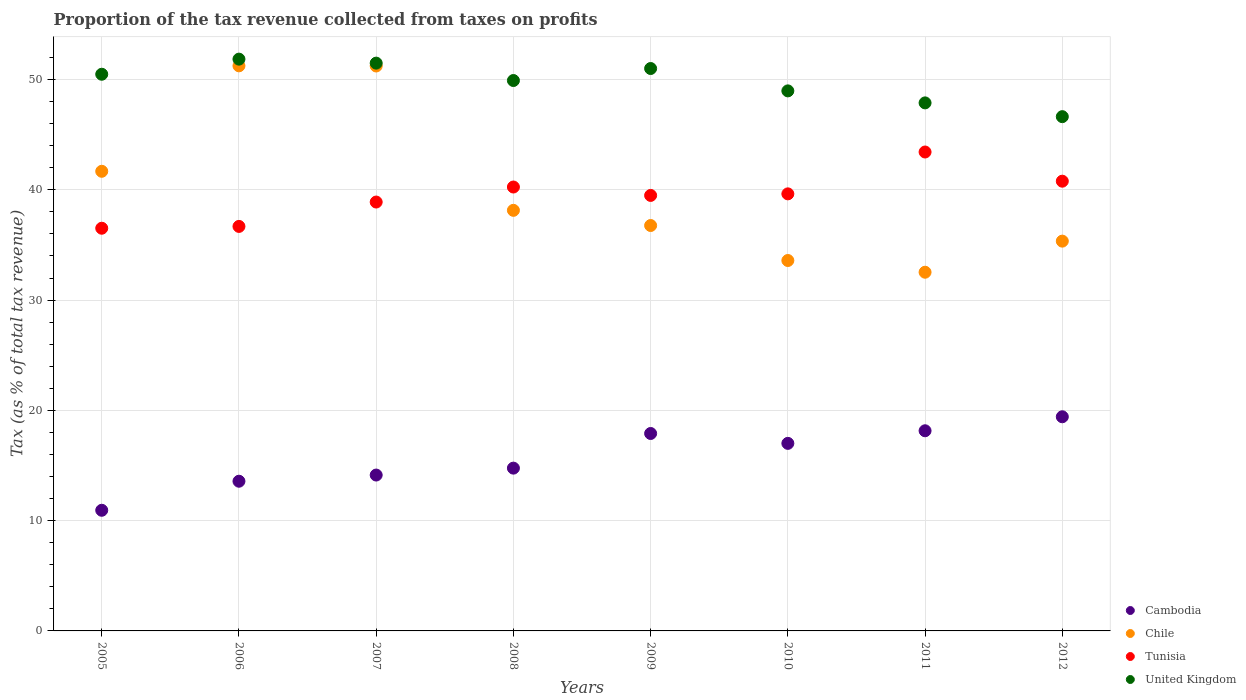How many different coloured dotlines are there?
Give a very brief answer. 4. What is the proportion of the tax revenue collected in Chile in 2012?
Make the answer very short. 35.35. Across all years, what is the maximum proportion of the tax revenue collected in Cambodia?
Your answer should be very brief. 19.42. Across all years, what is the minimum proportion of the tax revenue collected in Chile?
Offer a terse response. 32.53. What is the total proportion of the tax revenue collected in Chile in the graph?
Ensure brevity in your answer.  320.5. What is the difference between the proportion of the tax revenue collected in Tunisia in 2011 and that in 2012?
Give a very brief answer. 2.65. What is the difference between the proportion of the tax revenue collected in Tunisia in 2010 and the proportion of the tax revenue collected in United Kingdom in 2007?
Provide a short and direct response. -11.85. What is the average proportion of the tax revenue collected in Tunisia per year?
Ensure brevity in your answer.  39.46. In the year 2008, what is the difference between the proportion of the tax revenue collected in Chile and proportion of the tax revenue collected in United Kingdom?
Keep it short and to the point. -11.77. In how many years, is the proportion of the tax revenue collected in Cambodia greater than 8 %?
Offer a very short reply. 8. What is the ratio of the proportion of the tax revenue collected in Cambodia in 2008 to that in 2009?
Provide a succinct answer. 0.82. What is the difference between the highest and the second highest proportion of the tax revenue collected in Tunisia?
Offer a terse response. 2.65. What is the difference between the highest and the lowest proportion of the tax revenue collected in Cambodia?
Make the answer very short. 8.48. In how many years, is the proportion of the tax revenue collected in Tunisia greater than the average proportion of the tax revenue collected in Tunisia taken over all years?
Make the answer very short. 5. Is the sum of the proportion of the tax revenue collected in Chile in 2006 and 2012 greater than the maximum proportion of the tax revenue collected in United Kingdom across all years?
Ensure brevity in your answer.  Yes. Is it the case that in every year, the sum of the proportion of the tax revenue collected in United Kingdom and proportion of the tax revenue collected in Chile  is greater than the sum of proportion of the tax revenue collected in Tunisia and proportion of the tax revenue collected in Cambodia?
Make the answer very short. No. Is it the case that in every year, the sum of the proportion of the tax revenue collected in Cambodia and proportion of the tax revenue collected in Tunisia  is greater than the proportion of the tax revenue collected in United Kingdom?
Make the answer very short. No. Does the proportion of the tax revenue collected in Tunisia monotonically increase over the years?
Keep it short and to the point. No. Is the proportion of the tax revenue collected in Cambodia strictly greater than the proportion of the tax revenue collected in United Kingdom over the years?
Your answer should be very brief. No. How many dotlines are there?
Your answer should be compact. 4. Does the graph contain any zero values?
Make the answer very short. No. Does the graph contain grids?
Make the answer very short. Yes. What is the title of the graph?
Provide a short and direct response. Proportion of the tax revenue collected from taxes on profits. What is the label or title of the Y-axis?
Make the answer very short. Tax (as % of total tax revenue). What is the Tax (as % of total tax revenue) of Cambodia in 2005?
Your response must be concise. 10.94. What is the Tax (as % of total tax revenue) of Chile in 2005?
Ensure brevity in your answer.  41.68. What is the Tax (as % of total tax revenue) of Tunisia in 2005?
Keep it short and to the point. 36.51. What is the Tax (as % of total tax revenue) of United Kingdom in 2005?
Ensure brevity in your answer.  50.48. What is the Tax (as % of total tax revenue) in Cambodia in 2006?
Offer a terse response. 13.57. What is the Tax (as % of total tax revenue) of Chile in 2006?
Ensure brevity in your answer.  51.24. What is the Tax (as % of total tax revenue) of Tunisia in 2006?
Offer a very short reply. 36.68. What is the Tax (as % of total tax revenue) in United Kingdom in 2006?
Ensure brevity in your answer.  51.85. What is the Tax (as % of total tax revenue) of Cambodia in 2007?
Your response must be concise. 14.13. What is the Tax (as % of total tax revenue) of Chile in 2007?
Offer a very short reply. 51.23. What is the Tax (as % of total tax revenue) of Tunisia in 2007?
Your answer should be compact. 38.89. What is the Tax (as % of total tax revenue) of United Kingdom in 2007?
Provide a short and direct response. 51.49. What is the Tax (as % of total tax revenue) of Cambodia in 2008?
Your answer should be compact. 14.76. What is the Tax (as % of total tax revenue) of Chile in 2008?
Ensure brevity in your answer.  38.14. What is the Tax (as % of total tax revenue) in Tunisia in 2008?
Ensure brevity in your answer.  40.25. What is the Tax (as % of total tax revenue) in United Kingdom in 2008?
Your answer should be very brief. 49.91. What is the Tax (as % of total tax revenue) in Cambodia in 2009?
Your response must be concise. 17.9. What is the Tax (as % of total tax revenue) in Chile in 2009?
Your answer should be compact. 36.76. What is the Tax (as % of total tax revenue) of Tunisia in 2009?
Your answer should be very brief. 39.49. What is the Tax (as % of total tax revenue) of United Kingdom in 2009?
Provide a short and direct response. 51. What is the Tax (as % of total tax revenue) in Cambodia in 2010?
Give a very brief answer. 17.01. What is the Tax (as % of total tax revenue) of Chile in 2010?
Your answer should be compact. 33.59. What is the Tax (as % of total tax revenue) of Tunisia in 2010?
Keep it short and to the point. 39.63. What is the Tax (as % of total tax revenue) in United Kingdom in 2010?
Provide a succinct answer. 48.97. What is the Tax (as % of total tax revenue) in Cambodia in 2011?
Your answer should be compact. 18.15. What is the Tax (as % of total tax revenue) of Chile in 2011?
Your response must be concise. 32.53. What is the Tax (as % of total tax revenue) of Tunisia in 2011?
Ensure brevity in your answer.  43.43. What is the Tax (as % of total tax revenue) of United Kingdom in 2011?
Your response must be concise. 47.88. What is the Tax (as % of total tax revenue) in Cambodia in 2012?
Offer a very short reply. 19.42. What is the Tax (as % of total tax revenue) of Chile in 2012?
Your response must be concise. 35.35. What is the Tax (as % of total tax revenue) in Tunisia in 2012?
Give a very brief answer. 40.78. What is the Tax (as % of total tax revenue) in United Kingdom in 2012?
Make the answer very short. 46.63. Across all years, what is the maximum Tax (as % of total tax revenue) of Cambodia?
Provide a succinct answer. 19.42. Across all years, what is the maximum Tax (as % of total tax revenue) of Chile?
Your answer should be compact. 51.24. Across all years, what is the maximum Tax (as % of total tax revenue) in Tunisia?
Provide a succinct answer. 43.43. Across all years, what is the maximum Tax (as % of total tax revenue) of United Kingdom?
Ensure brevity in your answer.  51.85. Across all years, what is the minimum Tax (as % of total tax revenue) in Cambodia?
Offer a very short reply. 10.94. Across all years, what is the minimum Tax (as % of total tax revenue) in Chile?
Your answer should be compact. 32.53. Across all years, what is the minimum Tax (as % of total tax revenue) in Tunisia?
Your answer should be compact. 36.51. Across all years, what is the minimum Tax (as % of total tax revenue) in United Kingdom?
Keep it short and to the point. 46.63. What is the total Tax (as % of total tax revenue) in Cambodia in the graph?
Keep it short and to the point. 125.89. What is the total Tax (as % of total tax revenue) in Chile in the graph?
Offer a terse response. 320.5. What is the total Tax (as % of total tax revenue) of Tunisia in the graph?
Your response must be concise. 315.67. What is the total Tax (as % of total tax revenue) in United Kingdom in the graph?
Ensure brevity in your answer.  398.2. What is the difference between the Tax (as % of total tax revenue) of Cambodia in 2005 and that in 2006?
Provide a short and direct response. -2.63. What is the difference between the Tax (as % of total tax revenue) in Chile in 2005 and that in 2006?
Offer a terse response. -9.56. What is the difference between the Tax (as % of total tax revenue) in Tunisia in 2005 and that in 2006?
Ensure brevity in your answer.  -0.17. What is the difference between the Tax (as % of total tax revenue) in United Kingdom in 2005 and that in 2006?
Your answer should be compact. -1.37. What is the difference between the Tax (as % of total tax revenue) in Cambodia in 2005 and that in 2007?
Make the answer very short. -3.19. What is the difference between the Tax (as % of total tax revenue) in Chile in 2005 and that in 2007?
Make the answer very short. -9.55. What is the difference between the Tax (as % of total tax revenue) in Tunisia in 2005 and that in 2007?
Offer a terse response. -2.38. What is the difference between the Tax (as % of total tax revenue) of United Kingdom in 2005 and that in 2007?
Offer a terse response. -1.01. What is the difference between the Tax (as % of total tax revenue) in Cambodia in 2005 and that in 2008?
Offer a very short reply. -3.82. What is the difference between the Tax (as % of total tax revenue) in Chile in 2005 and that in 2008?
Offer a terse response. 3.54. What is the difference between the Tax (as % of total tax revenue) of Tunisia in 2005 and that in 2008?
Your response must be concise. -3.74. What is the difference between the Tax (as % of total tax revenue) of United Kingdom in 2005 and that in 2008?
Make the answer very short. 0.57. What is the difference between the Tax (as % of total tax revenue) in Cambodia in 2005 and that in 2009?
Your answer should be very brief. -6.96. What is the difference between the Tax (as % of total tax revenue) in Chile in 2005 and that in 2009?
Your answer should be very brief. 4.92. What is the difference between the Tax (as % of total tax revenue) of Tunisia in 2005 and that in 2009?
Give a very brief answer. -2.98. What is the difference between the Tax (as % of total tax revenue) in United Kingdom in 2005 and that in 2009?
Offer a very short reply. -0.52. What is the difference between the Tax (as % of total tax revenue) of Cambodia in 2005 and that in 2010?
Make the answer very short. -6.07. What is the difference between the Tax (as % of total tax revenue) in Chile in 2005 and that in 2010?
Offer a terse response. 8.09. What is the difference between the Tax (as % of total tax revenue) in Tunisia in 2005 and that in 2010?
Give a very brief answer. -3.12. What is the difference between the Tax (as % of total tax revenue) in United Kingdom in 2005 and that in 2010?
Provide a succinct answer. 1.51. What is the difference between the Tax (as % of total tax revenue) in Cambodia in 2005 and that in 2011?
Keep it short and to the point. -7.21. What is the difference between the Tax (as % of total tax revenue) in Chile in 2005 and that in 2011?
Keep it short and to the point. 9.15. What is the difference between the Tax (as % of total tax revenue) in Tunisia in 2005 and that in 2011?
Ensure brevity in your answer.  -6.91. What is the difference between the Tax (as % of total tax revenue) of United Kingdom in 2005 and that in 2011?
Your answer should be very brief. 2.6. What is the difference between the Tax (as % of total tax revenue) in Cambodia in 2005 and that in 2012?
Your response must be concise. -8.48. What is the difference between the Tax (as % of total tax revenue) of Chile in 2005 and that in 2012?
Provide a succinct answer. 6.33. What is the difference between the Tax (as % of total tax revenue) in Tunisia in 2005 and that in 2012?
Provide a succinct answer. -4.27. What is the difference between the Tax (as % of total tax revenue) in United Kingdom in 2005 and that in 2012?
Provide a succinct answer. 3.85. What is the difference between the Tax (as % of total tax revenue) in Cambodia in 2006 and that in 2007?
Ensure brevity in your answer.  -0.56. What is the difference between the Tax (as % of total tax revenue) in Chile in 2006 and that in 2007?
Offer a terse response. 0.01. What is the difference between the Tax (as % of total tax revenue) of Tunisia in 2006 and that in 2007?
Your answer should be very brief. -2.21. What is the difference between the Tax (as % of total tax revenue) in United Kingdom in 2006 and that in 2007?
Ensure brevity in your answer.  0.36. What is the difference between the Tax (as % of total tax revenue) in Cambodia in 2006 and that in 2008?
Ensure brevity in your answer.  -1.19. What is the difference between the Tax (as % of total tax revenue) of Chile in 2006 and that in 2008?
Provide a short and direct response. 13.1. What is the difference between the Tax (as % of total tax revenue) of Tunisia in 2006 and that in 2008?
Give a very brief answer. -3.57. What is the difference between the Tax (as % of total tax revenue) in United Kingdom in 2006 and that in 2008?
Your answer should be compact. 1.94. What is the difference between the Tax (as % of total tax revenue) of Cambodia in 2006 and that in 2009?
Your answer should be very brief. -4.33. What is the difference between the Tax (as % of total tax revenue) in Chile in 2006 and that in 2009?
Provide a succinct answer. 14.48. What is the difference between the Tax (as % of total tax revenue) in Tunisia in 2006 and that in 2009?
Offer a terse response. -2.81. What is the difference between the Tax (as % of total tax revenue) in United Kingdom in 2006 and that in 2009?
Your response must be concise. 0.85. What is the difference between the Tax (as % of total tax revenue) of Cambodia in 2006 and that in 2010?
Your response must be concise. -3.43. What is the difference between the Tax (as % of total tax revenue) of Chile in 2006 and that in 2010?
Your response must be concise. 17.65. What is the difference between the Tax (as % of total tax revenue) of Tunisia in 2006 and that in 2010?
Offer a terse response. -2.95. What is the difference between the Tax (as % of total tax revenue) of United Kingdom in 2006 and that in 2010?
Give a very brief answer. 2.88. What is the difference between the Tax (as % of total tax revenue) in Cambodia in 2006 and that in 2011?
Your response must be concise. -4.58. What is the difference between the Tax (as % of total tax revenue) in Chile in 2006 and that in 2011?
Your answer should be very brief. 18.71. What is the difference between the Tax (as % of total tax revenue) of Tunisia in 2006 and that in 2011?
Offer a very short reply. -6.75. What is the difference between the Tax (as % of total tax revenue) in United Kingdom in 2006 and that in 2011?
Offer a terse response. 3.97. What is the difference between the Tax (as % of total tax revenue) in Cambodia in 2006 and that in 2012?
Ensure brevity in your answer.  -5.84. What is the difference between the Tax (as % of total tax revenue) in Chile in 2006 and that in 2012?
Give a very brief answer. 15.9. What is the difference between the Tax (as % of total tax revenue) of Tunisia in 2006 and that in 2012?
Give a very brief answer. -4.1. What is the difference between the Tax (as % of total tax revenue) of United Kingdom in 2006 and that in 2012?
Give a very brief answer. 5.22. What is the difference between the Tax (as % of total tax revenue) of Cambodia in 2007 and that in 2008?
Ensure brevity in your answer.  -0.63. What is the difference between the Tax (as % of total tax revenue) of Chile in 2007 and that in 2008?
Provide a succinct answer. 13.09. What is the difference between the Tax (as % of total tax revenue) in Tunisia in 2007 and that in 2008?
Make the answer very short. -1.36. What is the difference between the Tax (as % of total tax revenue) in United Kingdom in 2007 and that in 2008?
Provide a succinct answer. 1.58. What is the difference between the Tax (as % of total tax revenue) of Cambodia in 2007 and that in 2009?
Give a very brief answer. -3.77. What is the difference between the Tax (as % of total tax revenue) of Chile in 2007 and that in 2009?
Your answer should be compact. 14.46. What is the difference between the Tax (as % of total tax revenue) in Tunisia in 2007 and that in 2009?
Your answer should be compact. -0.6. What is the difference between the Tax (as % of total tax revenue) in United Kingdom in 2007 and that in 2009?
Keep it short and to the point. 0.49. What is the difference between the Tax (as % of total tax revenue) of Cambodia in 2007 and that in 2010?
Provide a succinct answer. -2.87. What is the difference between the Tax (as % of total tax revenue) in Chile in 2007 and that in 2010?
Give a very brief answer. 17.64. What is the difference between the Tax (as % of total tax revenue) of Tunisia in 2007 and that in 2010?
Ensure brevity in your answer.  -0.74. What is the difference between the Tax (as % of total tax revenue) of United Kingdom in 2007 and that in 2010?
Keep it short and to the point. 2.52. What is the difference between the Tax (as % of total tax revenue) of Cambodia in 2007 and that in 2011?
Provide a short and direct response. -4.02. What is the difference between the Tax (as % of total tax revenue) of Chile in 2007 and that in 2011?
Make the answer very short. 18.7. What is the difference between the Tax (as % of total tax revenue) in Tunisia in 2007 and that in 2011?
Offer a very short reply. -4.54. What is the difference between the Tax (as % of total tax revenue) of United Kingdom in 2007 and that in 2011?
Your answer should be very brief. 3.61. What is the difference between the Tax (as % of total tax revenue) of Cambodia in 2007 and that in 2012?
Your answer should be very brief. -5.28. What is the difference between the Tax (as % of total tax revenue) in Chile in 2007 and that in 2012?
Provide a succinct answer. 15.88. What is the difference between the Tax (as % of total tax revenue) in Tunisia in 2007 and that in 2012?
Keep it short and to the point. -1.89. What is the difference between the Tax (as % of total tax revenue) of United Kingdom in 2007 and that in 2012?
Offer a very short reply. 4.85. What is the difference between the Tax (as % of total tax revenue) of Cambodia in 2008 and that in 2009?
Offer a very short reply. -3.14. What is the difference between the Tax (as % of total tax revenue) in Chile in 2008 and that in 2009?
Provide a short and direct response. 1.38. What is the difference between the Tax (as % of total tax revenue) of Tunisia in 2008 and that in 2009?
Make the answer very short. 0.76. What is the difference between the Tax (as % of total tax revenue) of United Kingdom in 2008 and that in 2009?
Your response must be concise. -1.09. What is the difference between the Tax (as % of total tax revenue) of Cambodia in 2008 and that in 2010?
Give a very brief answer. -2.25. What is the difference between the Tax (as % of total tax revenue) in Chile in 2008 and that in 2010?
Offer a terse response. 4.55. What is the difference between the Tax (as % of total tax revenue) in Tunisia in 2008 and that in 2010?
Make the answer very short. 0.62. What is the difference between the Tax (as % of total tax revenue) of United Kingdom in 2008 and that in 2010?
Give a very brief answer. 0.94. What is the difference between the Tax (as % of total tax revenue) in Cambodia in 2008 and that in 2011?
Offer a very short reply. -3.39. What is the difference between the Tax (as % of total tax revenue) in Chile in 2008 and that in 2011?
Offer a very short reply. 5.61. What is the difference between the Tax (as % of total tax revenue) of Tunisia in 2008 and that in 2011?
Make the answer very short. -3.18. What is the difference between the Tax (as % of total tax revenue) of United Kingdom in 2008 and that in 2011?
Your response must be concise. 2.03. What is the difference between the Tax (as % of total tax revenue) in Cambodia in 2008 and that in 2012?
Provide a succinct answer. -4.66. What is the difference between the Tax (as % of total tax revenue) in Chile in 2008 and that in 2012?
Offer a very short reply. 2.79. What is the difference between the Tax (as % of total tax revenue) of Tunisia in 2008 and that in 2012?
Ensure brevity in your answer.  -0.53. What is the difference between the Tax (as % of total tax revenue) of United Kingdom in 2008 and that in 2012?
Give a very brief answer. 3.28. What is the difference between the Tax (as % of total tax revenue) in Cambodia in 2009 and that in 2010?
Offer a very short reply. 0.9. What is the difference between the Tax (as % of total tax revenue) in Chile in 2009 and that in 2010?
Ensure brevity in your answer.  3.17. What is the difference between the Tax (as % of total tax revenue) of Tunisia in 2009 and that in 2010?
Offer a very short reply. -0.14. What is the difference between the Tax (as % of total tax revenue) of United Kingdom in 2009 and that in 2010?
Keep it short and to the point. 2.03. What is the difference between the Tax (as % of total tax revenue) in Cambodia in 2009 and that in 2011?
Provide a short and direct response. -0.25. What is the difference between the Tax (as % of total tax revenue) in Chile in 2009 and that in 2011?
Provide a succinct answer. 4.24. What is the difference between the Tax (as % of total tax revenue) of Tunisia in 2009 and that in 2011?
Your response must be concise. -3.94. What is the difference between the Tax (as % of total tax revenue) of United Kingdom in 2009 and that in 2011?
Give a very brief answer. 3.12. What is the difference between the Tax (as % of total tax revenue) of Cambodia in 2009 and that in 2012?
Make the answer very short. -1.52. What is the difference between the Tax (as % of total tax revenue) of Chile in 2009 and that in 2012?
Your answer should be very brief. 1.42. What is the difference between the Tax (as % of total tax revenue) of Tunisia in 2009 and that in 2012?
Provide a succinct answer. -1.29. What is the difference between the Tax (as % of total tax revenue) of United Kingdom in 2009 and that in 2012?
Provide a short and direct response. 4.37. What is the difference between the Tax (as % of total tax revenue) of Cambodia in 2010 and that in 2011?
Give a very brief answer. -1.14. What is the difference between the Tax (as % of total tax revenue) in Chile in 2010 and that in 2011?
Provide a succinct answer. 1.06. What is the difference between the Tax (as % of total tax revenue) of Tunisia in 2010 and that in 2011?
Offer a very short reply. -3.8. What is the difference between the Tax (as % of total tax revenue) in United Kingdom in 2010 and that in 2011?
Keep it short and to the point. 1.09. What is the difference between the Tax (as % of total tax revenue) in Cambodia in 2010 and that in 2012?
Keep it short and to the point. -2.41. What is the difference between the Tax (as % of total tax revenue) in Chile in 2010 and that in 2012?
Make the answer very short. -1.76. What is the difference between the Tax (as % of total tax revenue) of Tunisia in 2010 and that in 2012?
Your answer should be very brief. -1.15. What is the difference between the Tax (as % of total tax revenue) of United Kingdom in 2010 and that in 2012?
Offer a very short reply. 2.34. What is the difference between the Tax (as % of total tax revenue) of Cambodia in 2011 and that in 2012?
Keep it short and to the point. -1.27. What is the difference between the Tax (as % of total tax revenue) in Chile in 2011 and that in 2012?
Your answer should be compact. -2.82. What is the difference between the Tax (as % of total tax revenue) in Tunisia in 2011 and that in 2012?
Your answer should be very brief. 2.65. What is the difference between the Tax (as % of total tax revenue) in United Kingdom in 2011 and that in 2012?
Give a very brief answer. 1.25. What is the difference between the Tax (as % of total tax revenue) in Cambodia in 2005 and the Tax (as % of total tax revenue) in Chile in 2006?
Your response must be concise. -40.3. What is the difference between the Tax (as % of total tax revenue) in Cambodia in 2005 and the Tax (as % of total tax revenue) in Tunisia in 2006?
Offer a terse response. -25.74. What is the difference between the Tax (as % of total tax revenue) in Cambodia in 2005 and the Tax (as % of total tax revenue) in United Kingdom in 2006?
Provide a succinct answer. -40.91. What is the difference between the Tax (as % of total tax revenue) in Chile in 2005 and the Tax (as % of total tax revenue) in Tunisia in 2006?
Your answer should be very brief. 5. What is the difference between the Tax (as % of total tax revenue) of Chile in 2005 and the Tax (as % of total tax revenue) of United Kingdom in 2006?
Offer a very short reply. -10.17. What is the difference between the Tax (as % of total tax revenue) in Tunisia in 2005 and the Tax (as % of total tax revenue) in United Kingdom in 2006?
Offer a very short reply. -15.33. What is the difference between the Tax (as % of total tax revenue) of Cambodia in 2005 and the Tax (as % of total tax revenue) of Chile in 2007?
Provide a short and direct response. -40.29. What is the difference between the Tax (as % of total tax revenue) of Cambodia in 2005 and the Tax (as % of total tax revenue) of Tunisia in 2007?
Offer a terse response. -27.95. What is the difference between the Tax (as % of total tax revenue) of Cambodia in 2005 and the Tax (as % of total tax revenue) of United Kingdom in 2007?
Provide a succinct answer. -40.55. What is the difference between the Tax (as % of total tax revenue) of Chile in 2005 and the Tax (as % of total tax revenue) of Tunisia in 2007?
Your answer should be very brief. 2.79. What is the difference between the Tax (as % of total tax revenue) of Chile in 2005 and the Tax (as % of total tax revenue) of United Kingdom in 2007?
Your answer should be compact. -9.81. What is the difference between the Tax (as % of total tax revenue) of Tunisia in 2005 and the Tax (as % of total tax revenue) of United Kingdom in 2007?
Keep it short and to the point. -14.97. What is the difference between the Tax (as % of total tax revenue) of Cambodia in 2005 and the Tax (as % of total tax revenue) of Chile in 2008?
Offer a terse response. -27.2. What is the difference between the Tax (as % of total tax revenue) in Cambodia in 2005 and the Tax (as % of total tax revenue) in Tunisia in 2008?
Provide a short and direct response. -29.31. What is the difference between the Tax (as % of total tax revenue) of Cambodia in 2005 and the Tax (as % of total tax revenue) of United Kingdom in 2008?
Provide a succinct answer. -38.97. What is the difference between the Tax (as % of total tax revenue) in Chile in 2005 and the Tax (as % of total tax revenue) in Tunisia in 2008?
Ensure brevity in your answer.  1.43. What is the difference between the Tax (as % of total tax revenue) of Chile in 2005 and the Tax (as % of total tax revenue) of United Kingdom in 2008?
Your answer should be compact. -8.23. What is the difference between the Tax (as % of total tax revenue) in Tunisia in 2005 and the Tax (as % of total tax revenue) in United Kingdom in 2008?
Offer a terse response. -13.39. What is the difference between the Tax (as % of total tax revenue) of Cambodia in 2005 and the Tax (as % of total tax revenue) of Chile in 2009?
Provide a succinct answer. -25.82. What is the difference between the Tax (as % of total tax revenue) of Cambodia in 2005 and the Tax (as % of total tax revenue) of Tunisia in 2009?
Offer a terse response. -28.55. What is the difference between the Tax (as % of total tax revenue) of Cambodia in 2005 and the Tax (as % of total tax revenue) of United Kingdom in 2009?
Your answer should be very brief. -40.06. What is the difference between the Tax (as % of total tax revenue) in Chile in 2005 and the Tax (as % of total tax revenue) in Tunisia in 2009?
Provide a short and direct response. 2.19. What is the difference between the Tax (as % of total tax revenue) in Chile in 2005 and the Tax (as % of total tax revenue) in United Kingdom in 2009?
Provide a short and direct response. -9.32. What is the difference between the Tax (as % of total tax revenue) of Tunisia in 2005 and the Tax (as % of total tax revenue) of United Kingdom in 2009?
Make the answer very short. -14.48. What is the difference between the Tax (as % of total tax revenue) in Cambodia in 2005 and the Tax (as % of total tax revenue) in Chile in 2010?
Give a very brief answer. -22.65. What is the difference between the Tax (as % of total tax revenue) in Cambodia in 2005 and the Tax (as % of total tax revenue) in Tunisia in 2010?
Provide a succinct answer. -28.69. What is the difference between the Tax (as % of total tax revenue) of Cambodia in 2005 and the Tax (as % of total tax revenue) of United Kingdom in 2010?
Give a very brief answer. -38.03. What is the difference between the Tax (as % of total tax revenue) in Chile in 2005 and the Tax (as % of total tax revenue) in Tunisia in 2010?
Give a very brief answer. 2.05. What is the difference between the Tax (as % of total tax revenue) in Chile in 2005 and the Tax (as % of total tax revenue) in United Kingdom in 2010?
Offer a very short reply. -7.29. What is the difference between the Tax (as % of total tax revenue) of Tunisia in 2005 and the Tax (as % of total tax revenue) of United Kingdom in 2010?
Give a very brief answer. -12.46. What is the difference between the Tax (as % of total tax revenue) of Cambodia in 2005 and the Tax (as % of total tax revenue) of Chile in 2011?
Your answer should be very brief. -21.59. What is the difference between the Tax (as % of total tax revenue) of Cambodia in 2005 and the Tax (as % of total tax revenue) of Tunisia in 2011?
Make the answer very short. -32.49. What is the difference between the Tax (as % of total tax revenue) of Cambodia in 2005 and the Tax (as % of total tax revenue) of United Kingdom in 2011?
Offer a terse response. -36.94. What is the difference between the Tax (as % of total tax revenue) in Chile in 2005 and the Tax (as % of total tax revenue) in Tunisia in 2011?
Your response must be concise. -1.75. What is the difference between the Tax (as % of total tax revenue) in Chile in 2005 and the Tax (as % of total tax revenue) in United Kingdom in 2011?
Your answer should be compact. -6.2. What is the difference between the Tax (as % of total tax revenue) of Tunisia in 2005 and the Tax (as % of total tax revenue) of United Kingdom in 2011?
Your answer should be compact. -11.37. What is the difference between the Tax (as % of total tax revenue) in Cambodia in 2005 and the Tax (as % of total tax revenue) in Chile in 2012?
Your response must be concise. -24.41. What is the difference between the Tax (as % of total tax revenue) of Cambodia in 2005 and the Tax (as % of total tax revenue) of Tunisia in 2012?
Provide a short and direct response. -29.84. What is the difference between the Tax (as % of total tax revenue) in Cambodia in 2005 and the Tax (as % of total tax revenue) in United Kingdom in 2012?
Your response must be concise. -35.69. What is the difference between the Tax (as % of total tax revenue) in Chile in 2005 and the Tax (as % of total tax revenue) in Tunisia in 2012?
Give a very brief answer. 0.9. What is the difference between the Tax (as % of total tax revenue) in Chile in 2005 and the Tax (as % of total tax revenue) in United Kingdom in 2012?
Your answer should be very brief. -4.95. What is the difference between the Tax (as % of total tax revenue) of Tunisia in 2005 and the Tax (as % of total tax revenue) of United Kingdom in 2012?
Give a very brief answer. -10.12. What is the difference between the Tax (as % of total tax revenue) in Cambodia in 2006 and the Tax (as % of total tax revenue) in Chile in 2007?
Offer a terse response. -37.65. What is the difference between the Tax (as % of total tax revenue) in Cambodia in 2006 and the Tax (as % of total tax revenue) in Tunisia in 2007?
Make the answer very short. -25.32. What is the difference between the Tax (as % of total tax revenue) of Cambodia in 2006 and the Tax (as % of total tax revenue) of United Kingdom in 2007?
Provide a succinct answer. -37.91. What is the difference between the Tax (as % of total tax revenue) of Chile in 2006 and the Tax (as % of total tax revenue) of Tunisia in 2007?
Offer a very short reply. 12.35. What is the difference between the Tax (as % of total tax revenue) of Chile in 2006 and the Tax (as % of total tax revenue) of United Kingdom in 2007?
Provide a succinct answer. -0.25. What is the difference between the Tax (as % of total tax revenue) in Tunisia in 2006 and the Tax (as % of total tax revenue) in United Kingdom in 2007?
Your answer should be very brief. -14.81. What is the difference between the Tax (as % of total tax revenue) of Cambodia in 2006 and the Tax (as % of total tax revenue) of Chile in 2008?
Your answer should be compact. -24.56. What is the difference between the Tax (as % of total tax revenue) in Cambodia in 2006 and the Tax (as % of total tax revenue) in Tunisia in 2008?
Ensure brevity in your answer.  -26.68. What is the difference between the Tax (as % of total tax revenue) of Cambodia in 2006 and the Tax (as % of total tax revenue) of United Kingdom in 2008?
Give a very brief answer. -36.34. What is the difference between the Tax (as % of total tax revenue) in Chile in 2006 and the Tax (as % of total tax revenue) in Tunisia in 2008?
Keep it short and to the point. 10.99. What is the difference between the Tax (as % of total tax revenue) of Chile in 2006 and the Tax (as % of total tax revenue) of United Kingdom in 2008?
Offer a terse response. 1.33. What is the difference between the Tax (as % of total tax revenue) in Tunisia in 2006 and the Tax (as % of total tax revenue) in United Kingdom in 2008?
Your answer should be compact. -13.23. What is the difference between the Tax (as % of total tax revenue) of Cambodia in 2006 and the Tax (as % of total tax revenue) of Chile in 2009?
Your response must be concise. -23.19. What is the difference between the Tax (as % of total tax revenue) of Cambodia in 2006 and the Tax (as % of total tax revenue) of Tunisia in 2009?
Give a very brief answer. -25.92. What is the difference between the Tax (as % of total tax revenue) of Cambodia in 2006 and the Tax (as % of total tax revenue) of United Kingdom in 2009?
Ensure brevity in your answer.  -37.42. What is the difference between the Tax (as % of total tax revenue) in Chile in 2006 and the Tax (as % of total tax revenue) in Tunisia in 2009?
Ensure brevity in your answer.  11.75. What is the difference between the Tax (as % of total tax revenue) in Chile in 2006 and the Tax (as % of total tax revenue) in United Kingdom in 2009?
Your answer should be very brief. 0.24. What is the difference between the Tax (as % of total tax revenue) of Tunisia in 2006 and the Tax (as % of total tax revenue) of United Kingdom in 2009?
Ensure brevity in your answer.  -14.32. What is the difference between the Tax (as % of total tax revenue) of Cambodia in 2006 and the Tax (as % of total tax revenue) of Chile in 2010?
Ensure brevity in your answer.  -20.01. What is the difference between the Tax (as % of total tax revenue) of Cambodia in 2006 and the Tax (as % of total tax revenue) of Tunisia in 2010?
Make the answer very short. -26.06. What is the difference between the Tax (as % of total tax revenue) in Cambodia in 2006 and the Tax (as % of total tax revenue) in United Kingdom in 2010?
Keep it short and to the point. -35.4. What is the difference between the Tax (as % of total tax revenue) in Chile in 2006 and the Tax (as % of total tax revenue) in Tunisia in 2010?
Your answer should be compact. 11.61. What is the difference between the Tax (as % of total tax revenue) of Chile in 2006 and the Tax (as % of total tax revenue) of United Kingdom in 2010?
Ensure brevity in your answer.  2.27. What is the difference between the Tax (as % of total tax revenue) of Tunisia in 2006 and the Tax (as % of total tax revenue) of United Kingdom in 2010?
Keep it short and to the point. -12.29. What is the difference between the Tax (as % of total tax revenue) of Cambodia in 2006 and the Tax (as % of total tax revenue) of Chile in 2011?
Your answer should be very brief. -18.95. What is the difference between the Tax (as % of total tax revenue) in Cambodia in 2006 and the Tax (as % of total tax revenue) in Tunisia in 2011?
Your response must be concise. -29.85. What is the difference between the Tax (as % of total tax revenue) in Cambodia in 2006 and the Tax (as % of total tax revenue) in United Kingdom in 2011?
Provide a succinct answer. -34.31. What is the difference between the Tax (as % of total tax revenue) of Chile in 2006 and the Tax (as % of total tax revenue) of Tunisia in 2011?
Your answer should be compact. 7.81. What is the difference between the Tax (as % of total tax revenue) of Chile in 2006 and the Tax (as % of total tax revenue) of United Kingdom in 2011?
Your response must be concise. 3.36. What is the difference between the Tax (as % of total tax revenue) in Tunisia in 2006 and the Tax (as % of total tax revenue) in United Kingdom in 2011?
Your response must be concise. -11.2. What is the difference between the Tax (as % of total tax revenue) in Cambodia in 2006 and the Tax (as % of total tax revenue) in Chile in 2012?
Provide a succinct answer. -21.77. What is the difference between the Tax (as % of total tax revenue) of Cambodia in 2006 and the Tax (as % of total tax revenue) of Tunisia in 2012?
Offer a very short reply. -27.21. What is the difference between the Tax (as % of total tax revenue) of Cambodia in 2006 and the Tax (as % of total tax revenue) of United Kingdom in 2012?
Offer a terse response. -33.06. What is the difference between the Tax (as % of total tax revenue) of Chile in 2006 and the Tax (as % of total tax revenue) of Tunisia in 2012?
Provide a succinct answer. 10.46. What is the difference between the Tax (as % of total tax revenue) of Chile in 2006 and the Tax (as % of total tax revenue) of United Kingdom in 2012?
Provide a short and direct response. 4.61. What is the difference between the Tax (as % of total tax revenue) in Tunisia in 2006 and the Tax (as % of total tax revenue) in United Kingdom in 2012?
Offer a terse response. -9.95. What is the difference between the Tax (as % of total tax revenue) in Cambodia in 2007 and the Tax (as % of total tax revenue) in Chile in 2008?
Keep it short and to the point. -24. What is the difference between the Tax (as % of total tax revenue) in Cambodia in 2007 and the Tax (as % of total tax revenue) in Tunisia in 2008?
Your response must be concise. -26.12. What is the difference between the Tax (as % of total tax revenue) of Cambodia in 2007 and the Tax (as % of total tax revenue) of United Kingdom in 2008?
Offer a terse response. -35.77. What is the difference between the Tax (as % of total tax revenue) in Chile in 2007 and the Tax (as % of total tax revenue) in Tunisia in 2008?
Give a very brief answer. 10.97. What is the difference between the Tax (as % of total tax revenue) of Chile in 2007 and the Tax (as % of total tax revenue) of United Kingdom in 2008?
Ensure brevity in your answer.  1.32. What is the difference between the Tax (as % of total tax revenue) in Tunisia in 2007 and the Tax (as % of total tax revenue) in United Kingdom in 2008?
Make the answer very short. -11.02. What is the difference between the Tax (as % of total tax revenue) in Cambodia in 2007 and the Tax (as % of total tax revenue) in Chile in 2009?
Provide a succinct answer. -22.63. What is the difference between the Tax (as % of total tax revenue) of Cambodia in 2007 and the Tax (as % of total tax revenue) of Tunisia in 2009?
Ensure brevity in your answer.  -25.36. What is the difference between the Tax (as % of total tax revenue) of Cambodia in 2007 and the Tax (as % of total tax revenue) of United Kingdom in 2009?
Your answer should be very brief. -36.86. What is the difference between the Tax (as % of total tax revenue) in Chile in 2007 and the Tax (as % of total tax revenue) in Tunisia in 2009?
Your answer should be compact. 11.74. What is the difference between the Tax (as % of total tax revenue) in Chile in 2007 and the Tax (as % of total tax revenue) in United Kingdom in 2009?
Provide a short and direct response. 0.23. What is the difference between the Tax (as % of total tax revenue) of Tunisia in 2007 and the Tax (as % of total tax revenue) of United Kingdom in 2009?
Make the answer very short. -12.11. What is the difference between the Tax (as % of total tax revenue) of Cambodia in 2007 and the Tax (as % of total tax revenue) of Chile in 2010?
Provide a short and direct response. -19.45. What is the difference between the Tax (as % of total tax revenue) of Cambodia in 2007 and the Tax (as % of total tax revenue) of Tunisia in 2010?
Your answer should be compact. -25.5. What is the difference between the Tax (as % of total tax revenue) in Cambodia in 2007 and the Tax (as % of total tax revenue) in United Kingdom in 2010?
Offer a terse response. -34.84. What is the difference between the Tax (as % of total tax revenue) in Chile in 2007 and the Tax (as % of total tax revenue) in Tunisia in 2010?
Your answer should be very brief. 11.59. What is the difference between the Tax (as % of total tax revenue) in Chile in 2007 and the Tax (as % of total tax revenue) in United Kingdom in 2010?
Your answer should be very brief. 2.26. What is the difference between the Tax (as % of total tax revenue) of Tunisia in 2007 and the Tax (as % of total tax revenue) of United Kingdom in 2010?
Your response must be concise. -10.08. What is the difference between the Tax (as % of total tax revenue) in Cambodia in 2007 and the Tax (as % of total tax revenue) in Chile in 2011?
Your answer should be compact. -18.39. What is the difference between the Tax (as % of total tax revenue) in Cambodia in 2007 and the Tax (as % of total tax revenue) in Tunisia in 2011?
Ensure brevity in your answer.  -29.29. What is the difference between the Tax (as % of total tax revenue) of Cambodia in 2007 and the Tax (as % of total tax revenue) of United Kingdom in 2011?
Provide a succinct answer. -33.75. What is the difference between the Tax (as % of total tax revenue) in Chile in 2007 and the Tax (as % of total tax revenue) in Tunisia in 2011?
Give a very brief answer. 7.8. What is the difference between the Tax (as % of total tax revenue) in Chile in 2007 and the Tax (as % of total tax revenue) in United Kingdom in 2011?
Provide a short and direct response. 3.35. What is the difference between the Tax (as % of total tax revenue) in Tunisia in 2007 and the Tax (as % of total tax revenue) in United Kingdom in 2011?
Offer a very short reply. -8.99. What is the difference between the Tax (as % of total tax revenue) in Cambodia in 2007 and the Tax (as % of total tax revenue) in Chile in 2012?
Make the answer very short. -21.21. What is the difference between the Tax (as % of total tax revenue) in Cambodia in 2007 and the Tax (as % of total tax revenue) in Tunisia in 2012?
Offer a terse response. -26.65. What is the difference between the Tax (as % of total tax revenue) in Cambodia in 2007 and the Tax (as % of total tax revenue) in United Kingdom in 2012?
Keep it short and to the point. -32.5. What is the difference between the Tax (as % of total tax revenue) of Chile in 2007 and the Tax (as % of total tax revenue) of Tunisia in 2012?
Give a very brief answer. 10.45. What is the difference between the Tax (as % of total tax revenue) in Chile in 2007 and the Tax (as % of total tax revenue) in United Kingdom in 2012?
Offer a very short reply. 4.59. What is the difference between the Tax (as % of total tax revenue) in Tunisia in 2007 and the Tax (as % of total tax revenue) in United Kingdom in 2012?
Your answer should be very brief. -7.74. What is the difference between the Tax (as % of total tax revenue) of Cambodia in 2008 and the Tax (as % of total tax revenue) of Chile in 2009?
Ensure brevity in your answer.  -22. What is the difference between the Tax (as % of total tax revenue) in Cambodia in 2008 and the Tax (as % of total tax revenue) in Tunisia in 2009?
Give a very brief answer. -24.73. What is the difference between the Tax (as % of total tax revenue) of Cambodia in 2008 and the Tax (as % of total tax revenue) of United Kingdom in 2009?
Offer a terse response. -36.24. What is the difference between the Tax (as % of total tax revenue) in Chile in 2008 and the Tax (as % of total tax revenue) in Tunisia in 2009?
Your answer should be compact. -1.35. What is the difference between the Tax (as % of total tax revenue) of Chile in 2008 and the Tax (as % of total tax revenue) of United Kingdom in 2009?
Give a very brief answer. -12.86. What is the difference between the Tax (as % of total tax revenue) in Tunisia in 2008 and the Tax (as % of total tax revenue) in United Kingdom in 2009?
Provide a succinct answer. -10.75. What is the difference between the Tax (as % of total tax revenue) in Cambodia in 2008 and the Tax (as % of total tax revenue) in Chile in 2010?
Your answer should be compact. -18.83. What is the difference between the Tax (as % of total tax revenue) of Cambodia in 2008 and the Tax (as % of total tax revenue) of Tunisia in 2010?
Give a very brief answer. -24.87. What is the difference between the Tax (as % of total tax revenue) in Cambodia in 2008 and the Tax (as % of total tax revenue) in United Kingdom in 2010?
Your answer should be compact. -34.21. What is the difference between the Tax (as % of total tax revenue) of Chile in 2008 and the Tax (as % of total tax revenue) of Tunisia in 2010?
Offer a terse response. -1.49. What is the difference between the Tax (as % of total tax revenue) in Chile in 2008 and the Tax (as % of total tax revenue) in United Kingdom in 2010?
Your answer should be very brief. -10.83. What is the difference between the Tax (as % of total tax revenue) in Tunisia in 2008 and the Tax (as % of total tax revenue) in United Kingdom in 2010?
Your answer should be very brief. -8.72. What is the difference between the Tax (as % of total tax revenue) in Cambodia in 2008 and the Tax (as % of total tax revenue) in Chile in 2011?
Offer a terse response. -17.77. What is the difference between the Tax (as % of total tax revenue) in Cambodia in 2008 and the Tax (as % of total tax revenue) in Tunisia in 2011?
Your answer should be compact. -28.67. What is the difference between the Tax (as % of total tax revenue) of Cambodia in 2008 and the Tax (as % of total tax revenue) of United Kingdom in 2011?
Give a very brief answer. -33.12. What is the difference between the Tax (as % of total tax revenue) in Chile in 2008 and the Tax (as % of total tax revenue) in Tunisia in 2011?
Make the answer very short. -5.29. What is the difference between the Tax (as % of total tax revenue) of Chile in 2008 and the Tax (as % of total tax revenue) of United Kingdom in 2011?
Provide a succinct answer. -9.74. What is the difference between the Tax (as % of total tax revenue) of Tunisia in 2008 and the Tax (as % of total tax revenue) of United Kingdom in 2011?
Offer a very short reply. -7.63. What is the difference between the Tax (as % of total tax revenue) of Cambodia in 2008 and the Tax (as % of total tax revenue) of Chile in 2012?
Give a very brief answer. -20.58. What is the difference between the Tax (as % of total tax revenue) of Cambodia in 2008 and the Tax (as % of total tax revenue) of Tunisia in 2012?
Make the answer very short. -26.02. What is the difference between the Tax (as % of total tax revenue) in Cambodia in 2008 and the Tax (as % of total tax revenue) in United Kingdom in 2012?
Your response must be concise. -31.87. What is the difference between the Tax (as % of total tax revenue) of Chile in 2008 and the Tax (as % of total tax revenue) of Tunisia in 2012?
Give a very brief answer. -2.64. What is the difference between the Tax (as % of total tax revenue) of Chile in 2008 and the Tax (as % of total tax revenue) of United Kingdom in 2012?
Provide a short and direct response. -8.49. What is the difference between the Tax (as % of total tax revenue) in Tunisia in 2008 and the Tax (as % of total tax revenue) in United Kingdom in 2012?
Your answer should be compact. -6.38. What is the difference between the Tax (as % of total tax revenue) of Cambodia in 2009 and the Tax (as % of total tax revenue) of Chile in 2010?
Ensure brevity in your answer.  -15.69. What is the difference between the Tax (as % of total tax revenue) of Cambodia in 2009 and the Tax (as % of total tax revenue) of Tunisia in 2010?
Offer a terse response. -21.73. What is the difference between the Tax (as % of total tax revenue) of Cambodia in 2009 and the Tax (as % of total tax revenue) of United Kingdom in 2010?
Your answer should be very brief. -31.07. What is the difference between the Tax (as % of total tax revenue) in Chile in 2009 and the Tax (as % of total tax revenue) in Tunisia in 2010?
Make the answer very short. -2.87. What is the difference between the Tax (as % of total tax revenue) in Chile in 2009 and the Tax (as % of total tax revenue) in United Kingdom in 2010?
Your answer should be very brief. -12.21. What is the difference between the Tax (as % of total tax revenue) of Tunisia in 2009 and the Tax (as % of total tax revenue) of United Kingdom in 2010?
Make the answer very short. -9.48. What is the difference between the Tax (as % of total tax revenue) in Cambodia in 2009 and the Tax (as % of total tax revenue) in Chile in 2011?
Keep it short and to the point. -14.62. What is the difference between the Tax (as % of total tax revenue) of Cambodia in 2009 and the Tax (as % of total tax revenue) of Tunisia in 2011?
Provide a short and direct response. -25.52. What is the difference between the Tax (as % of total tax revenue) in Cambodia in 2009 and the Tax (as % of total tax revenue) in United Kingdom in 2011?
Offer a very short reply. -29.98. What is the difference between the Tax (as % of total tax revenue) in Chile in 2009 and the Tax (as % of total tax revenue) in Tunisia in 2011?
Provide a short and direct response. -6.67. What is the difference between the Tax (as % of total tax revenue) in Chile in 2009 and the Tax (as % of total tax revenue) in United Kingdom in 2011?
Keep it short and to the point. -11.12. What is the difference between the Tax (as % of total tax revenue) in Tunisia in 2009 and the Tax (as % of total tax revenue) in United Kingdom in 2011?
Keep it short and to the point. -8.39. What is the difference between the Tax (as % of total tax revenue) of Cambodia in 2009 and the Tax (as % of total tax revenue) of Chile in 2012?
Keep it short and to the point. -17.44. What is the difference between the Tax (as % of total tax revenue) in Cambodia in 2009 and the Tax (as % of total tax revenue) in Tunisia in 2012?
Offer a terse response. -22.88. What is the difference between the Tax (as % of total tax revenue) of Cambodia in 2009 and the Tax (as % of total tax revenue) of United Kingdom in 2012?
Offer a very short reply. -28.73. What is the difference between the Tax (as % of total tax revenue) of Chile in 2009 and the Tax (as % of total tax revenue) of Tunisia in 2012?
Keep it short and to the point. -4.02. What is the difference between the Tax (as % of total tax revenue) of Chile in 2009 and the Tax (as % of total tax revenue) of United Kingdom in 2012?
Give a very brief answer. -9.87. What is the difference between the Tax (as % of total tax revenue) of Tunisia in 2009 and the Tax (as % of total tax revenue) of United Kingdom in 2012?
Your response must be concise. -7.14. What is the difference between the Tax (as % of total tax revenue) of Cambodia in 2010 and the Tax (as % of total tax revenue) of Chile in 2011?
Provide a succinct answer. -15.52. What is the difference between the Tax (as % of total tax revenue) in Cambodia in 2010 and the Tax (as % of total tax revenue) in Tunisia in 2011?
Offer a very short reply. -26.42. What is the difference between the Tax (as % of total tax revenue) in Cambodia in 2010 and the Tax (as % of total tax revenue) in United Kingdom in 2011?
Keep it short and to the point. -30.87. What is the difference between the Tax (as % of total tax revenue) in Chile in 2010 and the Tax (as % of total tax revenue) in Tunisia in 2011?
Provide a succinct answer. -9.84. What is the difference between the Tax (as % of total tax revenue) in Chile in 2010 and the Tax (as % of total tax revenue) in United Kingdom in 2011?
Make the answer very short. -14.29. What is the difference between the Tax (as % of total tax revenue) in Tunisia in 2010 and the Tax (as % of total tax revenue) in United Kingdom in 2011?
Offer a very short reply. -8.25. What is the difference between the Tax (as % of total tax revenue) in Cambodia in 2010 and the Tax (as % of total tax revenue) in Chile in 2012?
Ensure brevity in your answer.  -18.34. What is the difference between the Tax (as % of total tax revenue) of Cambodia in 2010 and the Tax (as % of total tax revenue) of Tunisia in 2012?
Offer a terse response. -23.77. What is the difference between the Tax (as % of total tax revenue) in Cambodia in 2010 and the Tax (as % of total tax revenue) in United Kingdom in 2012?
Keep it short and to the point. -29.63. What is the difference between the Tax (as % of total tax revenue) in Chile in 2010 and the Tax (as % of total tax revenue) in Tunisia in 2012?
Keep it short and to the point. -7.19. What is the difference between the Tax (as % of total tax revenue) of Chile in 2010 and the Tax (as % of total tax revenue) of United Kingdom in 2012?
Provide a short and direct response. -13.04. What is the difference between the Tax (as % of total tax revenue) in Tunisia in 2010 and the Tax (as % of total tax revenue) in United Kingdom in 2012?
Give a very brief answer. -7. What is the difference between the Tax (as % of total tax revenue) of Cambodia in 2011 and the Tax (as % of total tax revenue) of Chile in 2012?
Offer a very short reply. -17.2. What is the difference between the Tax (as % of total tax revenue) of Cambodia in 2011 and the Tax (as % of total tax revenue) of Tunisia in 2012?
Provide a short and direct response. -22.63. What is the difference between the Tax (as % of total tax revenue) of Cambodia in 2011 and the Tax (as % of total tax revenue) of United Kingdom in 2012?
Provide a succinct answer. -28.48. What is the difference between the Tax (as % of total tax revenue) in Chile in 2011 and the Tax (as % of total tax revenue) in Tunisia in 2012?
Offer a very short reply. -8.25. What is the difference between the Tax (as % of total tax revenue) in Chile in 2011 and the Tax (as % of total tax revenue) in United Kingdom in 2012?
Provide a short and direct response. -14.11. What is the difference between the Tax (as % of total tax revenue) of Tunisia in 2011 and the Tax (as % of total tax revenue) of United Kingdom in 2012?
Your answer should be compact. -3.21. What is the average Tax (as % of total tax revenue) in Cambodia per year?
Your answer should be compact. 15.74. What is the average Tax (as % of total tax revenue) of Chile per year?
Provide a succinct answer. 40.06. What is the average Tax (as % of total tax revenue) of Tunisia per year?
Offer a terse response. 39.46. What is the average Tax (as % of total tax revenue) in United Kingdom per year?
Provide a succinct answer. 49.78. In the year 2005, what is the difference between the Tax (as % of total tax revenue) of Cambodia and Tax (as % of total tax revenue) of Chile?
Your response must be concise. -30.74. In the year 2005, what is the difference between the Tax (as % of total tax revenue) in Cambodia and Tax (as % of total tax revenue) in Tunisia?
Provide a succinct answer. -25.58. In the year 2005, what is the difference between the Tax (as % of total tax revenue) in Cambodia and Tax (as % of total tax revenue) in United Kingdom?
Ensure brevity in your answer.  -39.54. In the year 2005, what is the difference between the Tax (as % of total tax revenue) in Chile and Tax (as % of total tax revenue) in Tunisia?
Your answer should be very brief. 5.16. In the year 2005, what is the difference between the Tax (as % of total tax revenue) of Chile and Tax (as % of total tax revenue) of United Kingdom?
Give a very brief answer. -8.8. In the year 2005, what is the difference between the Tax (as % of total tax revenue) of Tunisia and Tax (as % of total tax revenue) of United Kingdom?
Your answer should be very brief. -13.96. In the year 2006, what is the difference between the Tax (as % of total tax revenue) of Cambodia and Tax (as % of total tax revenue) of Chile?
Your answer should be compact. -37.67. In the year 2006, what is the difference between the Tax (as % of total tax revenue) of Cambodia and Tax (as % of total tax revenue) of Tunisia?
Provide a short and direct response. -23.11. In the year 2006, what is the difference between the Tax (as % of total tax revenue) in Cambodia and Tax (as % of total tax revenue) in United Kingdom?
Ensure brevity in your answer.  -38.27. In the year 2006, what is the difference between the Tax (as % of total tax revenue) of Chile and Tax (as % of total tax revenue) of Tunisia?
Your answer should be compact. 14.56. In the year 2006, what is the difference between the Tax (as % of total tax revenue) of Chile and Tax (as % of total tax revenue) of United Kingdom?
Keep it short and to the point. -0.61. In the year 2006, what is the difference between the Tax (as % of total tax revenue) of Tunisia and Tax (as % of total tax revenue) of United Kingdom?
Keep it short and to the point. -15.17. In the year 2007, what is the difference between the Tax (as % of total tax revenue) in Cambodia and Tax (as % of total tax revenue) in Chile?
Offer a very short reply. -37.09. In the year 2007, what is the difference between the Tax (as % of total tax revenue) of Cambodia and Tax (as % of total tax revenue) of Tunisia?
Ensure brevity in your answer.  -24.76. In the year 2007, what is the difference between the Tax (as % of total tax revenue) of Cambodia and Tax (as % of total tax revenue) of United Kingdom?
Provide a succinct answer. -37.35. In the year 2007, what is the difference between the Tax (as % of total tax revenue) of Chile and Tax (as % of total tax revenue) of Tunisia?
Offer a very short reply. 12.34. In the year 2007, what is the difference between the Tax (as % of total tax revenue) of Chile and Tax (as % of total tax revenue) of United Kingdom?
Make the answer very short. -0.26. In the year 2007, what is the difference between the Tax (as % of total tax revenue) in Tunisia and Tax (as % of total tax revenue) in United Kingdom?
Give a very brief answer. -12.6. In the year 2008, what is the difference between the Tax (as % of total tax revenue) of Cambodia and Tax (as % of total tax revenue) of Chile?
Provide a short and direct response. -23.38. In the year 2008, what is the difference between the Tax (as % of total tax revenue) in Cambodia and Tax (as % of total tax revenue) in Tunisia?
Ensure brevity in your answer.  -25.49. In the year 2008, what is the difference between the Tax (as % of total tax revenue) of Cambodia and Tax (as % of total tax revenue) of United Kingdom?
Keep it short and to the point. -35.15. In the year 2008, what is the difference between the Tax (as % of total tax revenue) in Chile and Tax (as % of total tax revenue) in Tunisia?
Your answer should be very brief. -2.11. In the year 2008, what is the difference between the Tax (as % of total tax revenue) of Chile and Tax (as % of total tax revenue) of United Kingdom?
Provide a short and direct response. -11.77. In the year 2008, what is the difference between the Tax (as % of total tax revenue) in Tunisia and Tax (as % of total tax revenue) in United Kingdom?
Your answer should be very brief. -9.66. In the year 2009, what is the difference between the Tax (as % of total tax revenue) in Cambodia and Tax (as % of total tax revenue) in Chile?
Provide a succinct answer. -18.86. In the year 2009, what is the difference between the Tax (as % of total tax revenue) of Cambodia and Tax (as % of total tax revenue) of Tunisia?
Your answer should be very brief. -21.59. In the year 2009, what is the difference between the Tax (as % of total tax revenue) of Cambodia and Tax (as % of total tax revenue) of United Kingdom?
Provide a short and direct response. -33.1. In the year 2009, what is the difference between the Tax (as % of total tax revenue) of Chile and Tax (as % of total tax revenue) of Tunisia?
Keep it short and to the point. -2.73. In the year 2009, what is the difference between the Tax (as % of total tax revenue) of Chile and Tax (as % of total tax revenue) of United Kingdom?
Your answer should be very brief. -14.24. In the year 2009, what is the difference between the Tax (as % of total tax revenue) in Tunisia and Tax (as % of total tax revenue) in United Kingdom?
Keep it short and to the point. -11.51. In the year 2010, what is the difference between the Tax (as % of total tax revenue) in Cambodia and Tax (as % of total tax revenue) in Chile?
Offer a terse response. -16.58. In the year 2010, what is the difference between the Tax (as % of total tax revenue) in Cambodia and Tax (as % of total tax revenue) in Tunisia?
Provide a succinct answer. -22.62. In the year 2010, what is the difference between the Tax (as % of total tax revenue) of Cambodia and Tax (as % of total tax revenue) of United Kingdom?
Keep it short and to the point. -31.96. In the year 2010, what is the difference between the Tax (as % of total tax revenue) of Chile and Tax (as % of total tax revenue) of Tunisia?
Provide a short and direct response. -6.04. In the year 2010, what is the difference between the Tax (as % of total tax revenue) in Chile and Tax (as % of total tax revenue) in United Kingdom?
Keep it short and to the point. -15.38. In the year 2010, what is the difference between the Tax (as % of total tax revenue) of Tunisia and Tax (as % of total tax revenue) of United Kingdom?
Give a very brief answer. -9.34. In the year 2011, what is the difference between the Tax (as % of total tax revenue) in Cambodia and Tax (as % of total tax revenue) in Chile?
Give a very brief answer. -14.38. In the year 2011, what is the difference between the Tax (as % of total tax revenue) of Cambodia and Tax (as % of total tax revenue) of Tunisia?
Provide a short and direct response. -25.28. In the year 2011, what is the difference between the Tax (as % of total tax revenue) of Cambodia and Tax (as % of total tax revenue) of United Kingdom?
Offer a very short reply. -29.73. In the year 2011, what is the difference between the Tax (as % of total tax revenue) of Chile and Tax (as % of total tax revenue) of Tunisia?
Offer a very short reply. -10.9. In the year 2011, what is the difference between the Tax (as % of total tax revenue) in Chile and Tax (as % of total tax revenue) in United Kingdom?
Keep it short and to the point. -15.35. In the year 2011, what is the difference between the Tax (as % of total tax revenue) in Tunisia and Tax (as % of total tax revenue) in United Kingdom?
Your answer should be compact. -4.45. In the year 2012, what is the difference between the Tax (as % of total tax revenue) in Cambodia and Tax (as % of total tax revenue) in Chile?
Your answer should be very brief. -15.93. In the year 2012, what is the difference between the Tax (as % of total tax revenue) in Cambodia and Tax (as % of total tax revenue) in Tunisia?
Give a very brief answer. -21.36. In the year 2012, what is the difference between the Tax (as % of total tax revenue) of Cambodia and Tax (as % of total tax revenue) of United Kingdom?
Your response must be concise. -27.21. In the year 2012, what is the difference between the Tax (as % of total tax revenue) in Chile and Tax (as % of total tax revenue) in Tunisia?
Your answer should be very brief. -5.44. In the year 2012, what is the difference between the Tax (as % of total tax revenue) in Chile and Tax (as % of total tax revenue) in United Kingdom?
Offer a very short reply. -11.29. In the year 2012, what is the difference between the Tax (as % of total tax revenue) in Tunisia and Tax (as % of total tax revenue) in United Kingdom?
Provide a short and direct response. -5.85. What is the ratio of the Tax (as % of total tax revenue) of Cambodia in 2005 to that in 2006?
Your answer should be compact. 0.81. What is the ratio of the Tax (as % of total tax revenue) in Chile in 2005 to that in 2006?
Provide a short and direct response. 0.81. What is the ratio of the Tax (as % of total tax revenue) of Tunisia in 2005 to that in 2006?
Your answer should be compact. 1. What is the ratio of the Tax (as % of total tax revenue) of United Kingdom in 2005 to that in 2006?
Offer a terse response. 0.97. What is the ratio of the Tax (as % of total tax revenue) of Cambodia in 2005 to that in 2007?
Offer a terse response. 0.77. What is the ratio of the Tax (as % of total tax revenue) in Chile in 2005 to that in 2007?
Offer a very short reply. 0.81. What is the ratio of the Tax (as % of total tax revenue) of Tunisia in 2005 to that in 2007?
Ensure brevity in your answer.  0.94. What is the ratio of the Tax (as % of total tax revenue) in United Kingdom in 2005 to that in 2007?
Ensure brevity in your answer.  0.98. What is the ratio of the Tax (as % of total tax revenue) of Cambodia in 2005 to that in 2008?
Offer a terse response. 0.74. What is the ratio of the Tax (as % of total tax revenue) in Chile in 2005 to that in 2008?
Offer a very short reply. 1.09. What is the ratio of the Tax (as % of total tax revenue) in Tunisia in 2005 to that in 2008?
Your response must be concise. 0.91. What is the ratio of the Tax (as % of total tax revenue) of United Kingdom in 2005 to that in 2008?
Keep it short and to the point. 1.01. What is the ratio of the Tax (as % of total tax revenue) in Cambodia in 2005 to that in 2009?
Your response must be concise. 0.61. What is the ratio of the Tax (as % of total tax revenue) of Chile in 2005 to that in 2009?
Your response must be concise. 1.13. What is the ratio of the Tax (as % of total tax revenue) in Tunisia in 2005 to that in 2009?
Offer a terse response. 0.92. What is the ratio of the Tax (as % of total tax revenue) of Cambodia in 2005 to that in 2010?
Offer a very short reply. 0.64. What is the ratio of the Tax (as % of total tax revenue) of Chile in 2005 to that in 2010?
Your response must be concise. 1.24. What is the ratio of the Tax (as % of total tax revenue) of Tunisia in 2005 to that in 2010?
Offer a terse response. 0.92. What is the ratio of the Tax (as % of total tax revenue) in United Kingdom in 2005 to that in 2010?
Your answer should be compact. 1.03. What is the ratio of the Tax (as % of total tax revenue) in Cambodia in 2005 to that in 2011?
Offer a terse response. 0.6. What is the ratio of the Tax (as % of total tax revenue) of Chile in 2005 to that in 2011?
Keep it short and to the point. 1.28. What is the ratio of the Tax (as % of total tax revenue) of Tunisia in 2005 to that in 2011?
Offer a very short reply. 0.84. What is the ratio of the Tax (as % of total tax revenue) of United Kingdom in 2005 to that in 2011?
Make the answer very short. 1.05. What is the ratio of the Tax (as % of total tax revenue) in Cambodia in 2005 to that in 2012?
Your response must be concise. 0.56. What is the ratio of the Tax (as % of total tax revenue) of Chile in 2005 to that in 2012?
Keep it short and to the point. 1.18. What is the ratio of the Tax (as % of total tax revenue) of Tunisia in 2005 to that in 2012?
Make the answer very short. 0.9. What is the ratio of the Tax (as % of total tax revenue) in United Kingdom in 2005 to that in 2012?
Your answer should be compact. 1.08. What is the ratio of the Tax (as % of total tax revenue) of Cambodia in 2006 to that in 2007?
Keep it short and to the point. 0.96. What is the ratio of the Tax (as % of total tax revenue) in Chile in 2006 to that in 2007?
Offer a terse response. 1. What is the ratio of the Tax (as % of total tax revenue) of Tunisia in 2006 to that in 2007?
Offer a very short reply. 0.94. What is the ratio of the Tax (as % of total tax revenue) of Cambodia in 2006 to that in 2008?
Your answer should be compact. 0.92. What is the ratio of the Tax (as % of total tax revenue) in Chile in 2006 to that in 2008?
Your answer should be very brief. 1.34. What is the ratio of the Tax (as % of total tax revenue) of Tunisia in 2006 to that in 2008?
Offer a very short reply. 0.91. What is the ratio of the Tax (as % of total tax revenue) in United Kingdom in 2006 to that in 2008?
Ensure brevity in your answer.  1.04. What is the ratio of the Tax (as % of total tax revenue) in Cambodia in 2006 to that in 2009?
Keep it short and to the point. 0.76. What is the ratio of the Tax (as % of total tax revenue) in Chile in 2006 to that in 2009?
Provide a short and direct response. 1.39. What is the ratio of the Tax (as % of total tax revenue) of Tunisia in 2006 to that in 2009?
Your response must be concise. 0.93. What is the ratio of the Tax (as % of total tax revenue) in United Kingdom in 2006 to that in 2009?
Your answer should be very brief. 1.02. What is the ratio of the Tax (as % of total tax revenue) in Cambodia in 2006 to that in 2010?
Keep it short and to the point. 0.8. What is the ratio of the Tax (as % of total tax revenue) in Chile in 2006 to that in 2010?
Ensure brevity in your answer.  1.53. What is the ratio of the Tax (as % of total tax revenue) in Tunisia in 2006 to that in 2010?
Offer a very short reply. 0.93. What is the ratio of the Tax (as % of total tax revenue) in United Kingdom in 2006 to that in 2010?
Your answer should be very brief. 1.06. What is the ratio of the Tax (as % of total tax revenue) of Cambodia in 2006 to that in 2011?
Keep it short and to the point. 0.75. What is the ratio of the Tax (as % of total tax revenue) in Chile in 2006 to that in 2011?
Provide a succinct answer. 1.58. What is the ratio of the Tax (as % of total tax revenue) of Tunisia in 2006 to that in 2011?
Your answer should be compact. 0.84. What is the ratio of the Tax (as % of total tax revenue) in United Kingdom in 2006 to that in 2011?
Make the answer very short. 1.08. What is the ratio of the Tax (as % of total tax revenue) of Cambodia in 2006 to that in 2012?
Make the answer very short. 0.7. What is the ratio of the Tax (as % of total tax revenue) in Chile in 2006 to that in 2012?
Your answer should be compact. 1.45. What is the ratio of the Tax (as % of total tax revenue) in Tunisia in 2006 to that in 2012?
Make the answer very short. 0.9. What is the ratio of the Tax (as % of total tax revenue) in United Kingdom in 2006 to that in 2012?
Provide a short and direct response. 1.11. What is the ratio of the Tax (as % of total tax revenue) in Cambodia in 2007 to that in 2008?
Provide a succinct answer. 0.96. What is the ratio of the Tax (as % of total tax revenue) of Chile in 2007 to that in 2008?
Your answer should be very brief. 1.34. What is the ratio of the Tax (as % of total tax revenue) of Tunisia in 2007 to that in 2008?
Offer a very short reply. 0.97. What is the ratio of the Tax (as % of total tax revenue) in United Kingdom in 2007 to that in 2008?
Provide a short and direct response. 1.03. What is the ratio of the Tax (as % of total tax revenue) of Cambodia in 2007 to that in 2009?
Give a very brief answer. 0.79. What is the ratio of the Tax (as % of total tax revenue) in Chile in 2007 to that in 2009?
Make the answer very short. 1.39. What is the ratio of the Tax (as % of total tax revenue) of Tunisia in 2007 to that in 2009?
Give a very brief answer. 0.98. What is the ratio of the Tax (as % of total tax revenue) of United Kingdom in 2007 to that in 2009?
Make the answer very short. 1.01. What is the ratio of the Tax (as % of total tax revenue) of Cambodia in 2007 to that in 2010?
Make the answer very short. 0.83. What is the ratio of the Tax (as % of total tax revenue) in Chile in 2007 to that in 2010?
Provide a succinct answer. 1.53. What is the ratio of the Tax (as % of total tax revenue) of Tunisia in 2007 to that in 2010?
Your answer should be very brief. 0.98. What is the ratio of the Tax (as % of total tax revenue) of United Kingdom in 2007 to that in 2010?
Provide a succinct answer. 1.05. What is the ratio of the Tax (as % of total tax revenue) of Cambodia in 2007 to that in 2011?
Ensure brevity in your answer.  0.78. What is the ratio of the Tax (as % of total tax revenue) in Chile in 2007 to that in 2011?
Give a very brief answer. 1.57. What is the ratio of the Tax (as % of total tax revenue) in Tunisia in 2007 to that in 2011?
Keep it short and to the point. 0.9. What is the ratio of the Tax (as % of total tax revenue) in United Kingdom in 2007 to that in 2011?
Keep it short and to the point. 1.08. What is the ratio of the Tax (as % of total tax revenue) in Cambodia in 2007 to that in 2012?
Provide a short and direct response. 0.73. What is the ratio of the Tax (as % of total tax revenue) in Chile in 2007 to that in 2012?
Provide a succinct answer. 1.45. What is the ratio of the Tax (as % of total tax revenue) in Tunisia in 2007 to that in 2012?
Your answer should be very brief. 0.95. What is the ratio of the Tax (as % of total tax revenue) of United Kingdom in 2007 to that in 2012?
Provide a succinct answer. 1.1. What is the ratio of the Tax (as % of total tax revenue) of Cambodia in 2008 to that in 2009?
Offer a very short reply. 0.82. What is the ratio of the Tax (as % of total tax revenue) in Chile in 2008 to that in 2009?
Your response must be concise. 1.04. What is the ratio of the Tax (as % of total tax revenue) in Tunisia in 2008 to that in 2009?
Provide a succinct answer. 1.02. What is the ratio of the Tax (as % of total tax revenue) in United Kingdom in 2008 to that in 2009?
Provide a succinct answer. 0.98. What is the ratio of the Tax (as % of total tax revenue) in Cambodia in 2008 to that in 2010?
Provide a short and direct response. 0.87. What is the ratio of the Tax (as % of total tax revenue) of Chile in 2008 to that in 2010?
Your answer should be very brief. 1.14. What is the ratio of the Tax (as % of total tax revenue) in Tunisia in 2008 to that in 2010?
Ensure brevity in your answer.  1.02. What is the ratio of the Tax (as % of total tax revenue) in United Kingdom in 2008 to that in 2010?
Your answer should be very brief. 1.02. What is the ratio of the Tax (as % of total tax revenue) of Cambodia in 2008 to that in 2011?
Make the answer very short. 0.81. What is the ratio of the Tax (as % of total tax revenue) of Chile in 2008 to that in 2011?
Keep it short and to the point. 1.17. What is the ratio of the Tax (as % of total tax revenue) of Tunisia in 2008 to that in 2011?
Give a very brief answer. 0.93. What is the ratio of the Tax (as % of total tax revenue) in United Kingdom in 2008 to that in 2011?
Ensure brevity in your answer.  1.04. What is the ratio of the Tax (as % of total tax revenue) of Cambodia in 2008 to that in 2012?
Keep it short and to the point. 0.76. What is the ratio of the Tax (as % of total tax revenue) of Chile in 2008 to that in 2012?
Ensure brevity in your answer.  1.08. What is the ratio of the Tax (as % of total tax revenue) of Tunisia in 2008 to that in 2012?
Make the answer very short. 0.99. What is the ratio of the Tax (as % of total tax revenue) in United Kingdom in 2008 to that in 2012?
Keep it short and to the point. 1.07. What is the ratio of the Tax (as % of total tax revenue) in Cambodia in 2009 to that in 2010?
Provide a short and direct response. 1.05. What is the ratio of the Tax (as % of total tax revenue) of Chile in 2009 to that in 2010?
Provide a succinct answer. 1.09. What is the ratio of the Tax (as % of total tax revenue) in Tunisia in 2009 to that in 2010?
Offer a terse response. 1. What is the ratio of the Tax (as % of total tax revenue) in United Kingdom in 2009 to that in 2010?
Your answer should be very brief. 1.04. What is the ratio of the Tax (as % of total tax revenue) in Cambodia in 2009 to that in 2011?
Provide a succinct answer. 0.99. What is the ratio of the Tax (as % of total tax revenue) in Chile in 2009 to that in 2011?
Keep it short and to the point. 1.13. What is the ratio of the Tax (as % of total tax revenue) of Tunisia in 2009 to that in 2011?
Keep it short and to the point. 0.91. What is the ratio of the Tax (as % of total tax revenue) of United Kingdom in 2009 to that in 2011?
Keep it short and to the point. 1.07. What is the ratio of the Tax (as % of total tax revenue) in Cambodia in 2009 to that in 2012?
Your answer should be compact. 0.92. What is the ratio of the Tax (as % of total tax revenue) in Chile in 2009 to that in 2012?
Give a very brief answer. 1.04. What is the ratio of the Tax (as % of total tax revenue) in Tunisia in 2009 to that in 2012?
Your answer should be very brief. 0.97. What is the ratio of the Tax (as % of total tax revenue) in United Kingdom in 2009 to that in 2012?
Ensure brevity in your answer.  1.09. What is the ratio of the Tax (as % of total tax revenue) of Cambodia in 2010 to that in 2011?
Your response must be concise. 0.94. What is the ratio of the Tax (as % of total tax revenue) of Chile in 2010 to that in 2011?
Ensure brevity in your answer.  1.03. What is the ratio of the Tax (as % of total tax revenue) in Tunisia in 2010 to that in 2011?
Offer a terse response. 0.91. What is the ratio of the Tax (as % of total tax revenue) in United Kingdom in 2010 to that in 2011?
Provide a succinct answer. 1.02. What is the ratio of the Tax (as % of total tax revenue) in Cambodia in 2010 to that in 2012?
Make the answer very short. 0.88. What is the ratio of the Tax (as % of total tax revenue) of Chile in 2010 to that in 2012?
Ensure brevity in your answer.  0.95. What is the ratio of the Tax (as % of total tax revenue) in Tunisia in 2010 to that in 2012?
Make the answer very short. 0.97. What is the ratio of the Tax (as % of total tax revenue) in United Kingdom in 2010 to that in 2012?
Your response must be concise. 1.05. What is the ratio of the Tax (as % of total tax revenue) of Cambodia in 2011 to that in 2012?
Offer a terse response. 0.93. What is the ratio of the Tax (as % of total tax revenue) in Chile in 2011 to that in 2012?
Provide a short and direct response. 0.92. What is the ratio of the Tax (as % of total tax revenue) of Tunisia in 2011 to that in 2012?
Your answer should be compact. 1.06. What is the ratio of the Tax (as % of total tax revenue) in United Kingdom in 2011 to that in 2012?
Provide a succinct answer. 1.03. What is the difference between the highest and the second highest Tax (as % of total tax revenue) in Cambodia?
Ensure brevity in your answer.  1.27. What is the difference between the highest and the second highest Tax (as % of total tax revenue) of Chile?
Offer a very short reply. 0.01. What is the difference between the highest and the second highest Tax (as % of total tax revenue) in Tunisia?
Keep it short and to the point. 2.65. What is the difference between the highest and the second highest Tax (as % of total tax revenue) of United Kingdom?
Your answer should be very brief. 0.36. What is the difference between the highest and the lowest Tax (as % of total tax revenue) of Cambodia?
Provide a succinct answer. 8.48. What is the difference between the highest and the lowest Tax (as % of total tax revenue) in Chile?
Make the answer very short. 18.71. What is the difference between the highest and the lowest Tax (as % of total tax revenue) in Tunisia?
Make the answer very short. 6.91. What is the difference between the highest and the lowest Tax (as % of total tax revenue) in United Kingdom?
Your answer should be very brief. 5.22. 